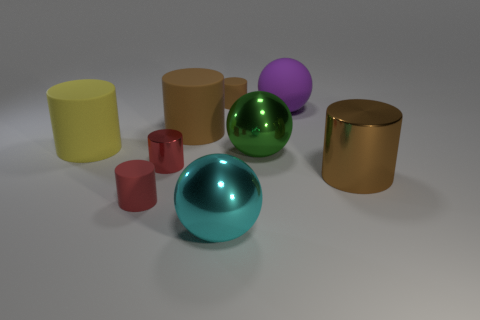Subtract all brown cylinders. How many were subtracted if there are1brown cylinders left? 2 Subtract all yellow spheres. How many brown cylinders are left? 3 Subtract all yellow cylinders. How many cylinders are left? 5 Subtract all large brown metal cylinders. How many cylinders are left? 5 Subtract all cyan cylinders. Subtract all brown cubes. How many cylinders are left? 6 Add 1 yellow metallic balls. How many objects exist? 10 Subtract all cylinders. How many objects are left? 3 Subtract all big yellow matte cylinders. Subtract all brown matte cylinders. How many objects are left? 6 Add 4 cyan shiny objects. How many cyan shiny objects are left? 5 Add 2 brown metallic cubes. How many brown metallic cubes exist? 2 